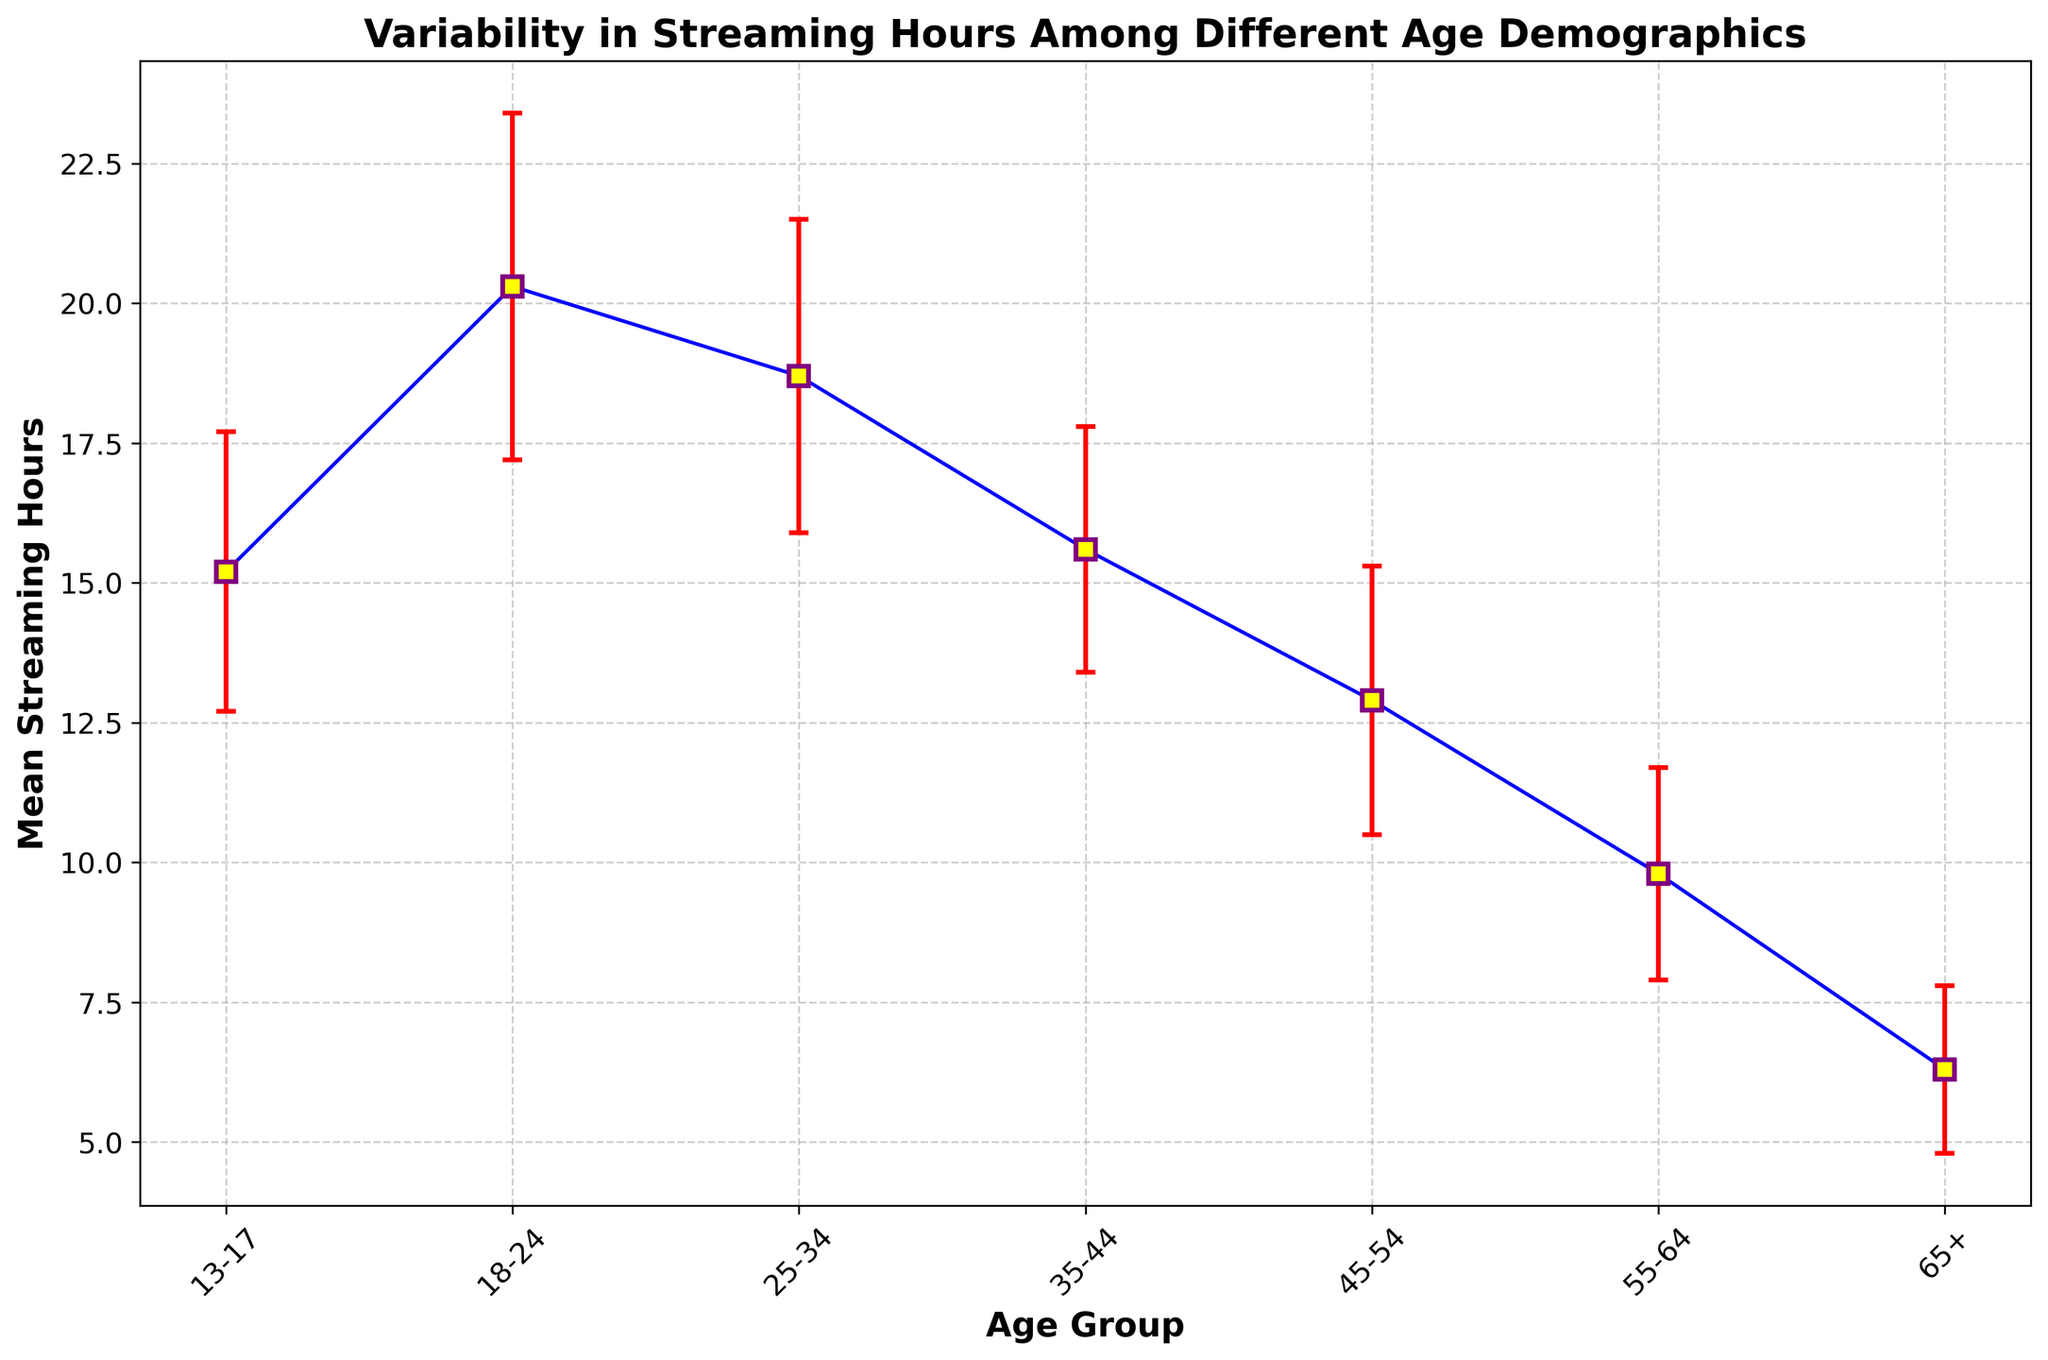What age group has the highest mean streaming hours? The age group 18-24 has the highest mean streaming hours, as indicated by the highest point on the vertical scale.
Answer: 18-24 Which age group has the lowest mean streaming hours? The age group 65+ has the lowest mean streaming hours, as indicated by the lowest point on the vertical scale.
Answer: 65+ What is the difference in mean streaming hours between the 18-24 and 65+ age groups? The mean streaming hours for 18-24 are 20.3, and for 65+, they are 6.3. The difference is 20.3 - 6.3 = 14.
Answer: 14 What is the average mean streaming hours of all age groups? Add the means of all age groups and divide by the number of age groups: (15.2 + 20.3 + 18.7 + 15.6 + 12.9 + 9.8 + 6.3) / 7 = 98.8 / 7 ≈ 14.1
Answer: 14.1 Which age group has the largest standard deviation? The age group 18-24 has the largest standard deviation of 3.1, indicated by the longest error bar length.
Answer: 18-24 How many more mean streaming hours do the 18-24 age group have compared to the 25-34 age group? The mean streaming hours for 18-24 are 20.3, and for 25-34, they are 18.7. The difference is 20.3 - 18.7 = 1.6.
Answer: 1.6 What is the sum of the highest and lowest mean streaming hours? The highest mean streaming hours are 20.3 (18-24), and the lowest are 6.3 (65+). The sum is 20.3 + 6.3 = 26.6.
Answer: 26.6 Which age group has a mean streaming hours closest to the average mean streaming hours of all groups? The average mean streaming hours of all groups is approximately 14.1. The age group 13-17 has mean streaming hours of 15.2, which is the closest to 14.1.
Answer: 13-17 Which age group’s mean streaming hours show the least variability? The age group 65+ has the smallest standard deviation of 1.5, indicated by the shortest error bar length.
Answer: 65+ How do the mean streaming hours for age groups 35-44 and 45-54 compare? The mean streaming hours for 35-44 are 15.6, and for 45-54, they are 12.9. Since 15.6 > 12.9, the 35-44 group streams more.
Answer: 35-44 stream more 